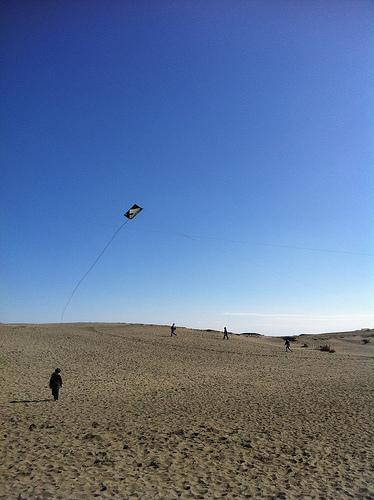Question: what is on the ground?
Choices:
A. Grass.
B. Sand.
C. Dirt.
D. Asphalt.
Answer with the letter. Answer: B Question: how many people are in the picture?
Choices:
A. Five.
B. Six.
C. Seven.
D. Four.
Answer with the letter. Answer: D Question: what are the people doing?
Choices:
A. Sunbathing.
B. Flying kites.
C. Swimming.
D. Looking at the stars.
Answer with the letter. Answer: B Question: what time of day is it?
Choices:
A. Noon.
B. Day time.
C. Nighttime.
D. Morning.
Answer with the letter. Answer: B Question: what color is the sky?
Choices:
A. Blue.
B. Green.
C. Orange.
D. Yellow.
Answer with the letter. Answer: A Question: who is flying the kite?
Choices:
A. The kids.
B. The teens.
C. The father and his son.
D. The young woman.
Answer with the letter. Answer: A 